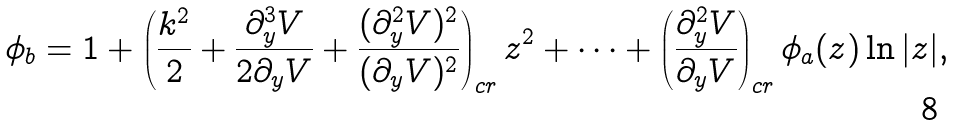<formula> <loc_0><loc_0><loc_500><loc_500>\phi _ { b } = 1 + \left ( \frac { k ^ { 2 } } { 2 } + \frac { \partial _ { y } ^ { 3 } V } { 2 \partial _ { y } V } + \frac { ( \partial _ { y } ^ { 2 } V ) ^ { 2 } } { ( \partial _ { y } V ) ^ { 2 } } \right ) _ { c r } z ^ { 2 } + \dots + \left ( \frac { \partial _ { y } ^ { 2 } V } { \partial _ { y } V } \right ) _ { c r } \phi _ { a } ( z ) \ln | z | ,</formula> 